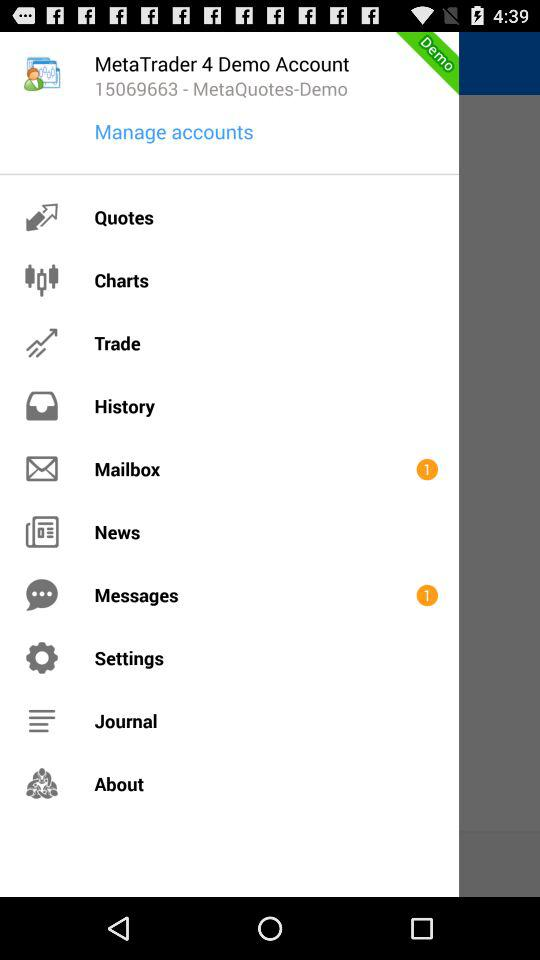Is there any unread mail in the mailbox?
When the provided information is insufficient, respond with <no answer>. <no answer> 